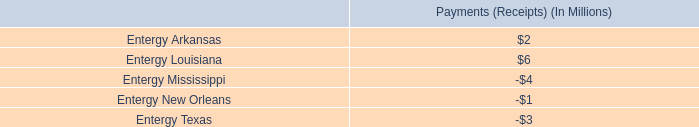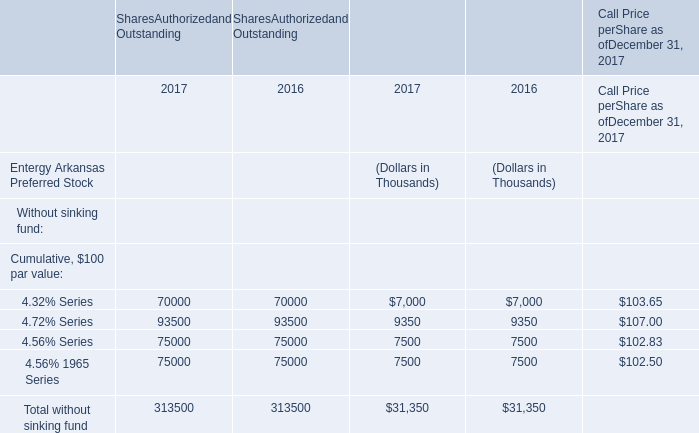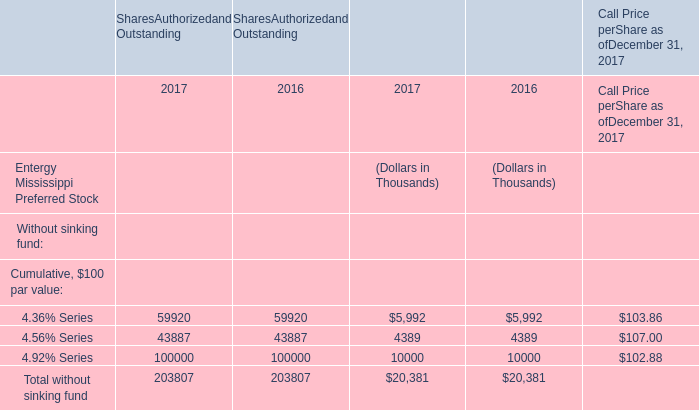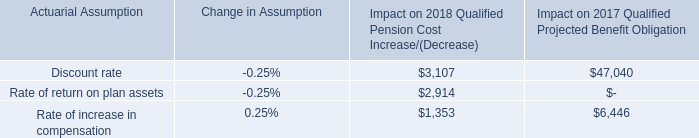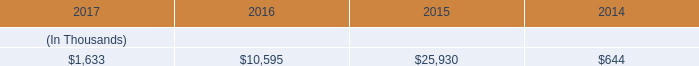what was the percent of the joint stipulation approve revenue increase based on formula rates 
Computations: (19.4 / 23.7)
Answer: 0.81857. 